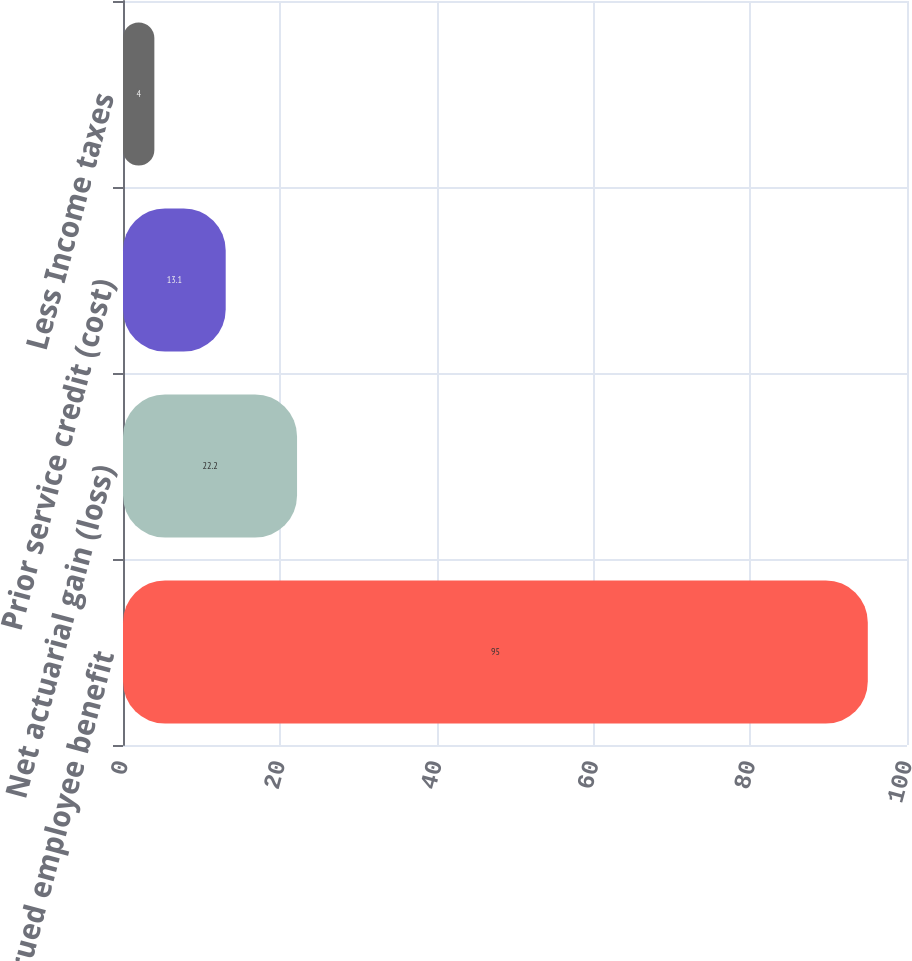Convert chart. <chart><loc_0><loc_0><loc_500><loc_500><bar_chart><fcel>Accrued employee benefit<fcel>Net actuarial gain (loss)<fcel>Prior service credit (cost)<fcel>Less Income taxes<nl><fcel>95<fcel>22.2<fcel>13.1<fcel>4<nl></chart> 